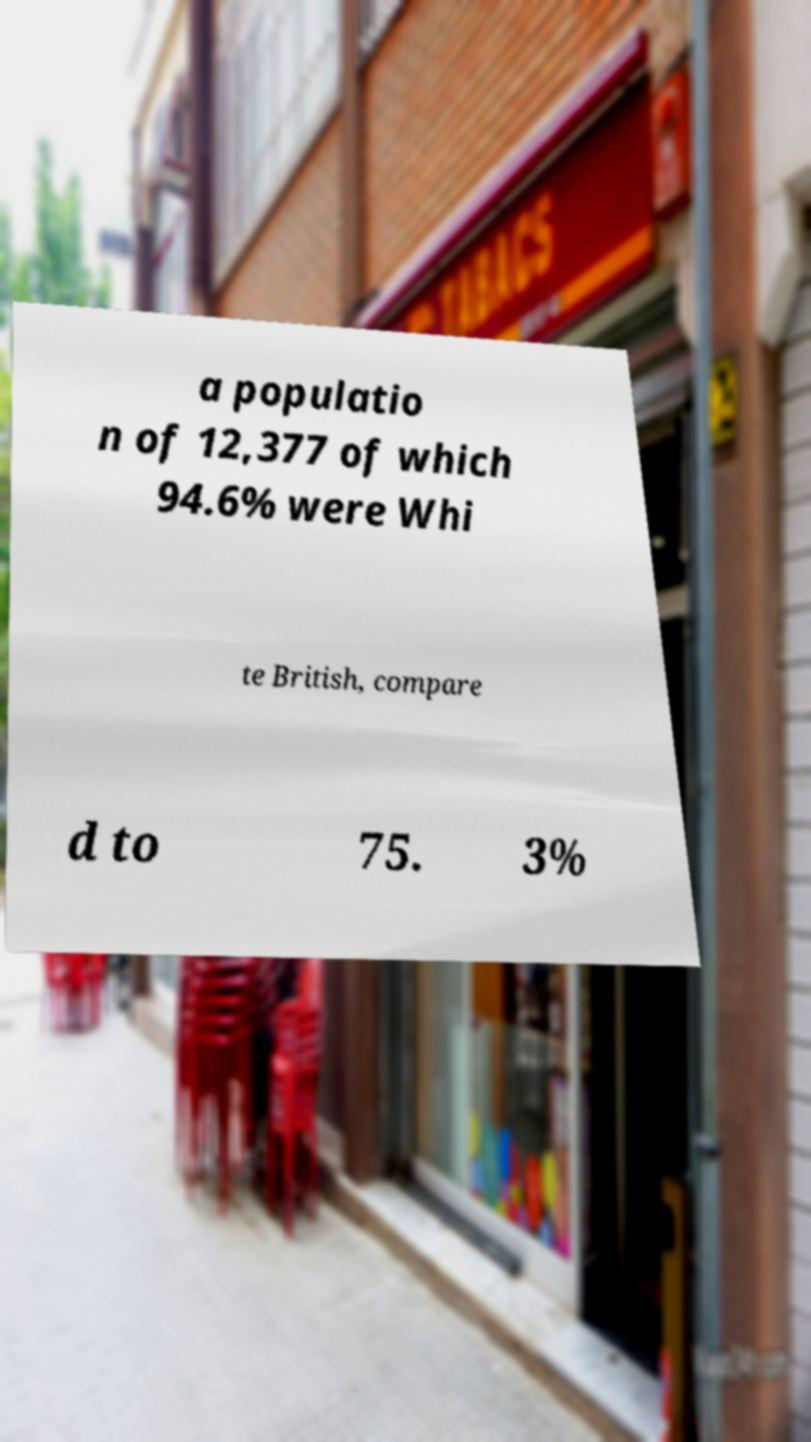Please identify and transcribe the text found in this image. a populatio n of 12,377 of which 94.6% were Whi te British, compare d to 75. 3% 